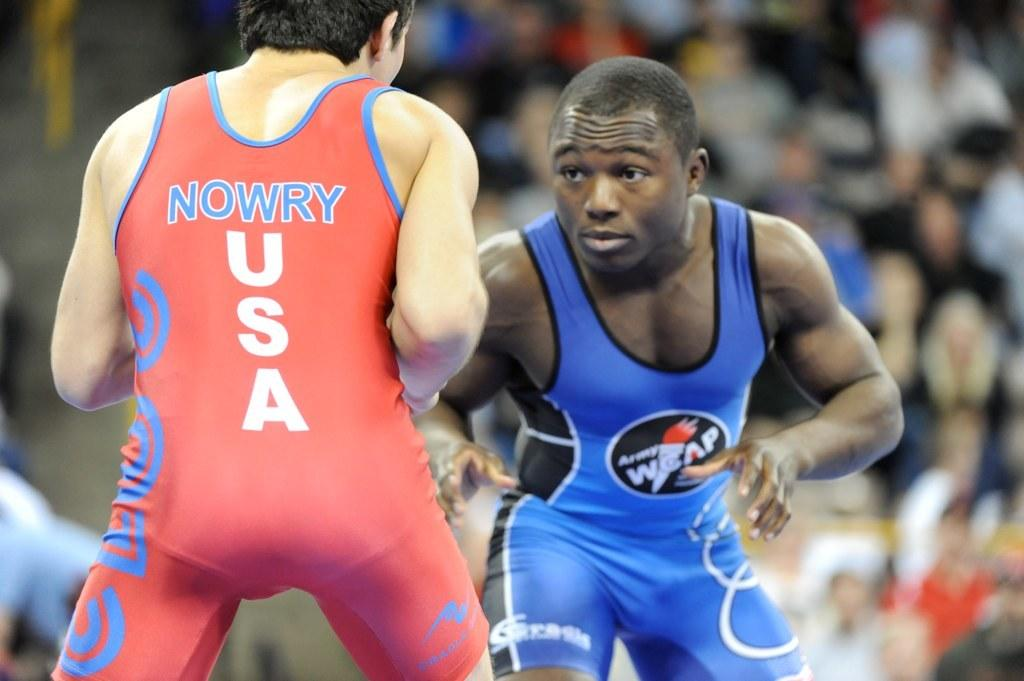Provide a one-sentence caption for the provided image. Two men are in a wrestling competition and one represents the USA. 